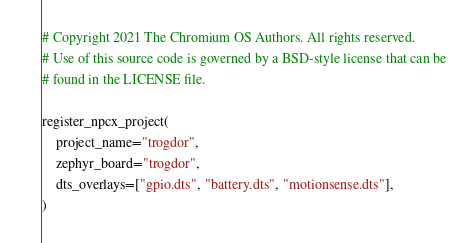Convert code to text. <code><loc_0><loc_0><loc_500><loc_500><_Python_># Copyright 2021 The Chromium OS Authors. All rights reserved.
# Use of this source code is governed by a BSD-style license that can be
# found in the LICENSE file.

register_npcx_project(
    project_name="trogdor",
    zephyr_board="trogdor",
    dts_overlays=["gpio.dts", "battery.dts", "motionsense.dts"],
)
</code> 